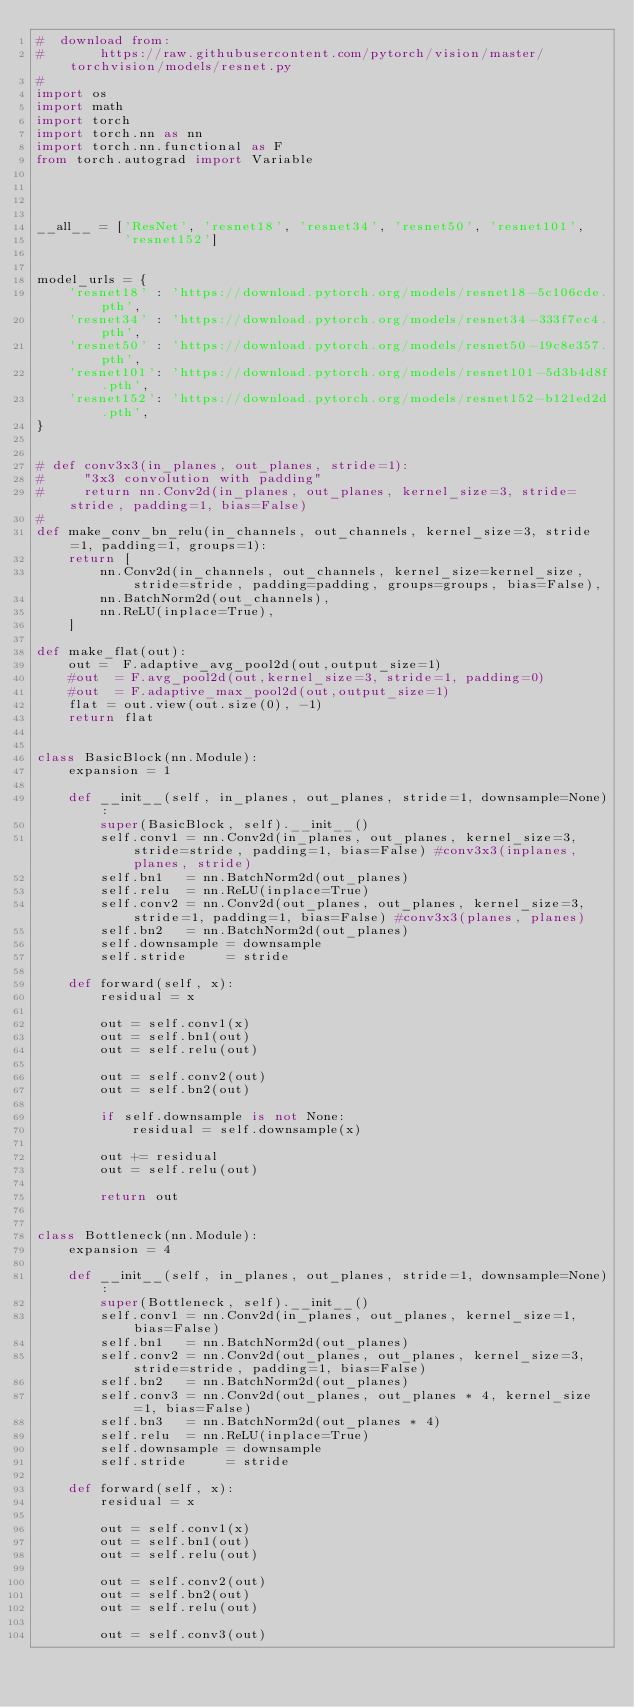<code> <loc_0><loc_0><loc_500><loc_500><_Python_>#  download from:
#       https://raw.githubusercontent.com/pytorch/vision/master/torchvision/models/resnet.py
#
import os
import math
import torch
import torch.nn as nn
import torch.nn.functional as F
from torch.autograd import Variable




__all__ = ['ResNet', 'resnet18', 'resnet34', 'resnet50', 'resnet101',
           'resnet152']


model_urls = {
    'resnet18' : 'https://download.pytorch.org/models/resnet18-5c106cde.pth',
    'resnet34' : 'https://download.pytorch.org/models/resnet34-333f7ec4.pth',
    'resnet50' : 'https://download.pytorch.org/models/resnet50-19c8e357.pth',
    'resnet101': 'https://download.pytorch.org/models/resnet101-5d3b4d8f.pth',
    'resnet152': 'https://download.pytorch.org/models/resnet152-b121ed2d.pth',
}


# def conv3x3(in_planes, out_planes, stride=1):
#     "3x3 convolution with padding"
#     return nn.Conv2d(in_planes, out_planes, kernel_size=3, stride=stride, padding=1, bias=False)
#
def make_conv_bn_relu(in_channels, out_channels, kernel_size=3, stride=1, padding=1, groups=1):
    return [
        nn.Conv2d(in_channels, out_channels, kernel_size=kernel_size, stride=stride, padding=padding, groups=groups, bias=False),
        nn.BatchNorm2d(out_channels),
        nn.ReLU(inplace=True),
    ]

def make_flat(out):
    out =  F.adaptive_avg_pool2d(out,output_size=1)
    #out  = F.avg_pool2d(out,kernel_size=3, stride=1, padding=0)
    #out  = F.adaptive_max_pool2d(out,output_size=1)
    flat = out.view(out.size(0), -1)
    return flat


class BasicBlock(nn.Module):
    expansion = 1

    def __init__(self, in_planes, out_planes, stride=1, downsample=None):
        super(BasicBlock, self).__init__()
        self.conv1 = nn.Conv2d(in_planes, out_planes, kernel_size=3, stride=stride, padding=1, bias=False) #conv3x3(inplanes, planes, stride)
        self.bn1   = nn.BatchNorm2d(out_planes)
        self.relu  = nn.ReLU(inplace=True)
        self.conv2 = nn.Conv2d(out_planes, out_planes, kernel_size=3, stride=1, padding=1, bias=False) #conv3x3(planes, planes)
        self.bn2   = nn.BatchNorm2d(out_planes)
        self.downsample = downsample
        self.stride     = stride

    def forward(self, x):
        residual = x

        out = self.conv1(x)
        out = self.bn1(out)
        out = self.relu(out)

        out = self.conv2(out)
        out = self.bn2(out)

        if self.downsample is not None:
            residual = self.downsample(x)

        out += residual
        out = self.relu(out)

        return out


class Bottleneck(nn.Module):
    expansion = 4

    def __init__(self, in_planes, out_planes, stride=1, downsample=None):
        super(Bottleneck, self).__init__()
        self.conv1 = nn.Conv2d(in_planes, out_planes, kernel_size=1, bias=False)
        self.bn1   = nn.BatchNorm2d(out_planes)
        self.conv2 = nn.Conv2d(out_planes, out_planes, kernel_size=3, stride=stride, padding=1, bias=False)
        self.bn2   = nn.BatchNorm2d(out_planes)
        self.conv3 = nn.Conv2d(out_planes, out_planes * 4, kernel_size=1, bias=False)
        self.bn3   = nn.BatchNorm2d(out_planes * 4)
        self.relu  = nn.ReLU(inplace=True)
        self.downsample = downsample
        self.stride     = stride

    def forward(self, x):
        residual = x

        out = self.conv1(x)
        out = self.bn1(out)
        out = self.relu(out)

        out = self.conv2(out)
        out = self.bn2(out)
        out = self.relu(out)

        out = self.conv3(out)</code> 